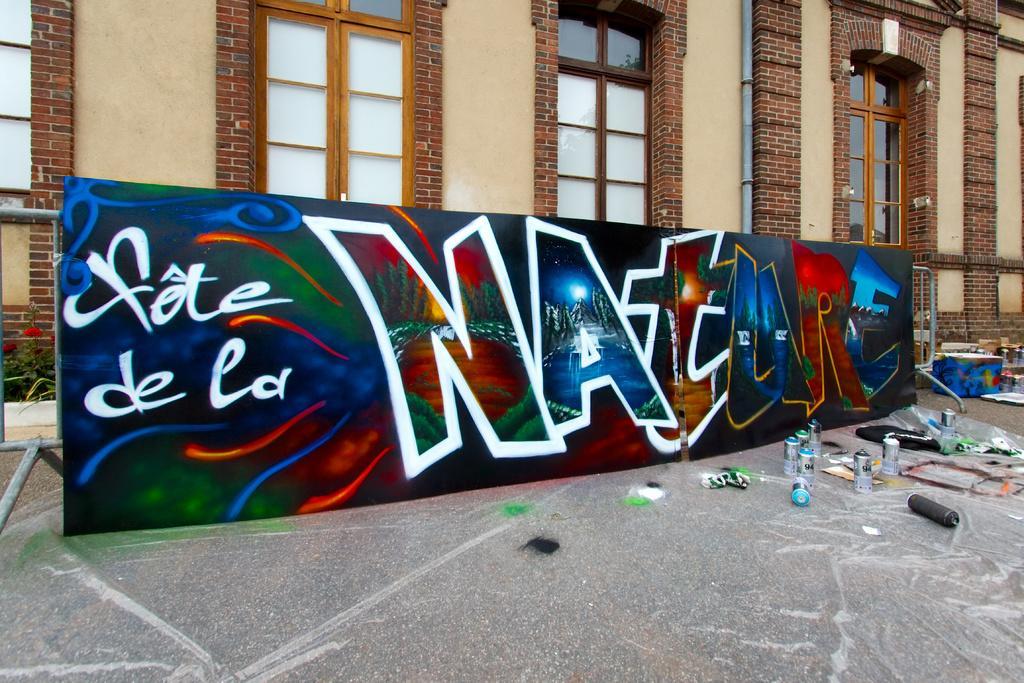In one or two sentences, can you explain what this image depicts? In the center of the image we can see board. At the bottom of the image we can see graffiti bottles on the floor. In the background we can see windows, pipe and building. 